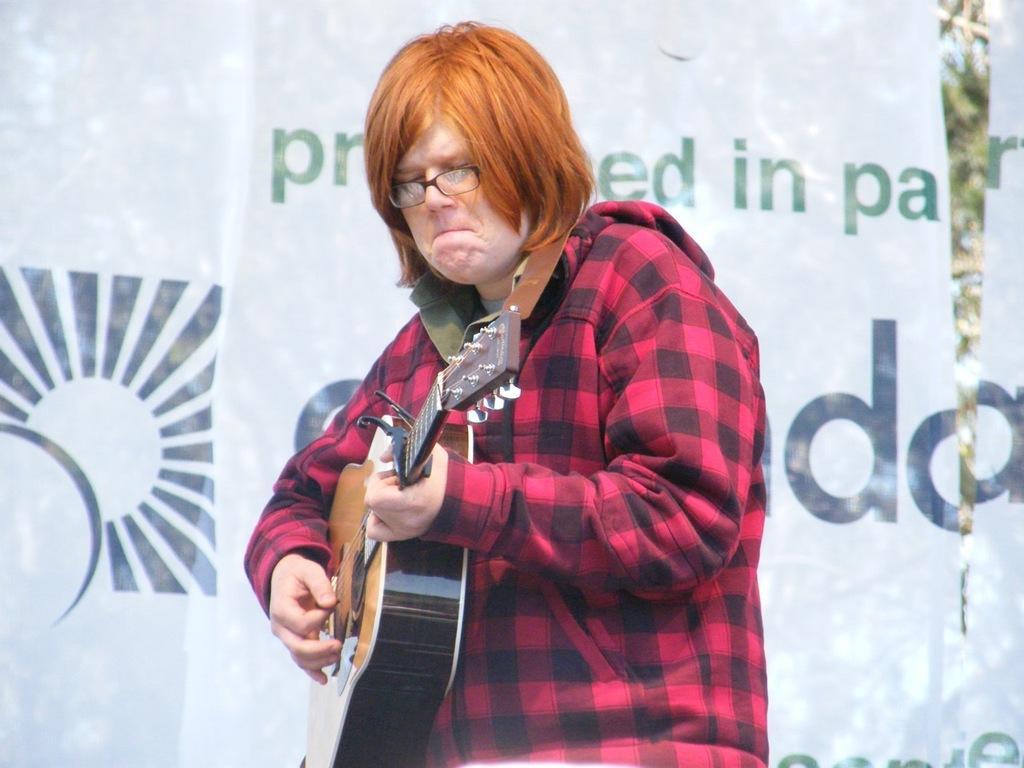In one or two sentences, can you explain what this image depicts? In this image we can see a person holding a guitar in his hands and playing it. In the background we can see a banner. 